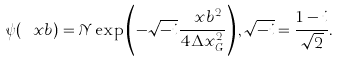Convert formula to latex. <formula><loc_0><loc_0><loc_500><loc_500>\psi ( \ x b ) = \mathcal { N } \exp \left ( - \sqrt { - i } \frac { \ x b ^ { 2 } } { 4 \Delta x _ { G } ^ { 2 } } \right ) , \sqrt { - i } = \frac { 1 - i } { \sqrt { 2 } } .</formula> 